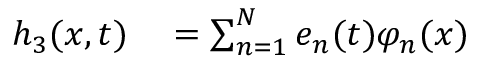Convert formula to latex. <formula><loc_0><loc_0><loc_500><loc_500>\begin{array} { r l } { h _ { 3 } ( x , t ) } & = \sum _ { n = 1 } ^ { N } e _ { n } ( t ) \varphi _ { n } ( x ) } \end{array}</formula> 